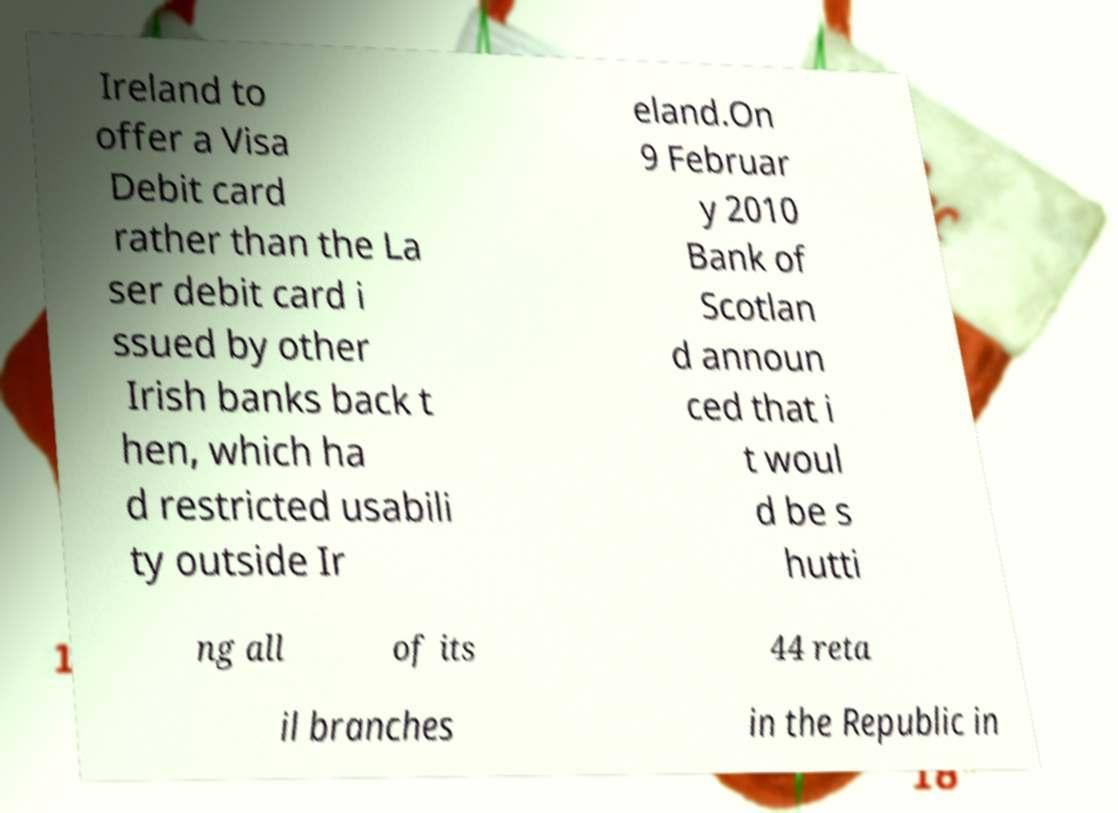There's text embedded in this image that I need extracted. Can you transcribe it verbatim? Ireland to offer a Visa Debit card rather than the La ser debit card i ssued by other Irish banks back t hen, which ha d restricted usabili ty outside Ir eland.On 9 Februar y 2010 Bank of Scotlan d announ ced that i t woul d be s hutti ng all of its 44 reta il branches in the Republic in 